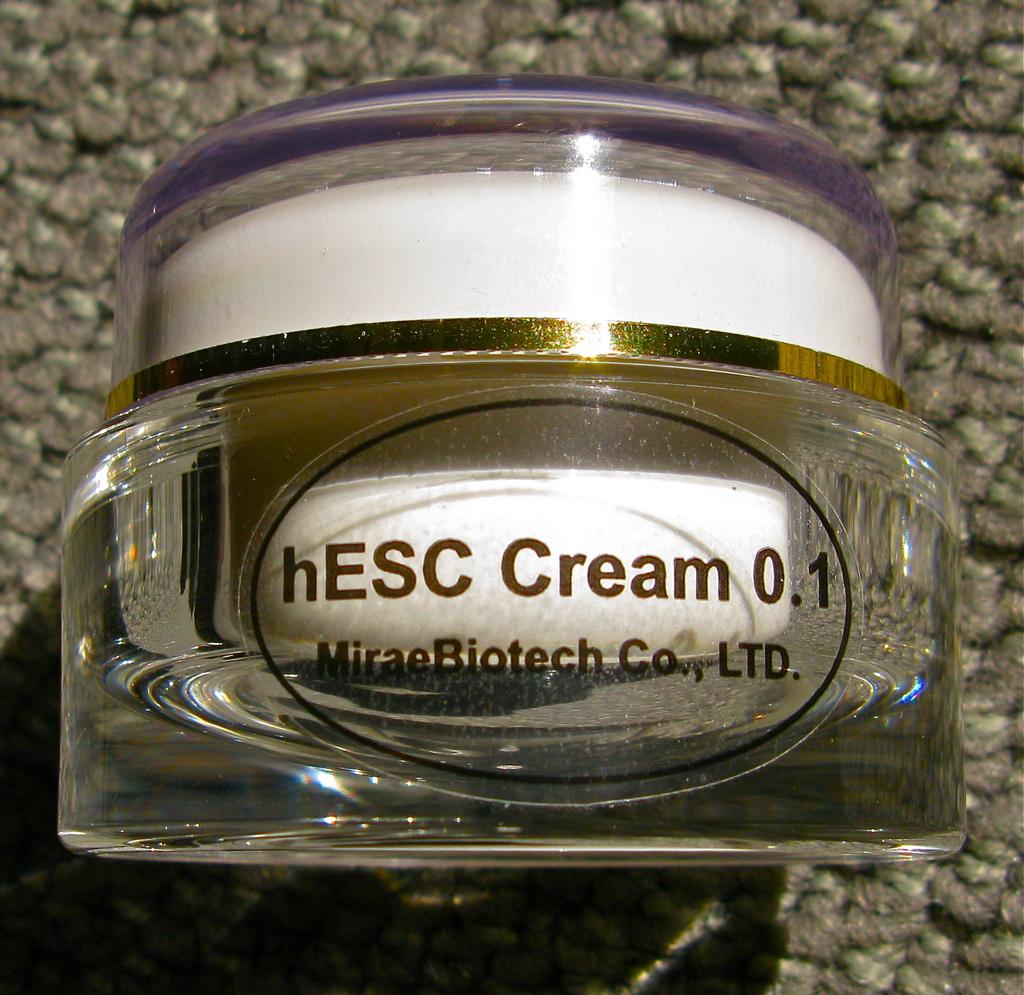What is the name of the product?
Your answer should be very brief. Hesc cream 0.1. 